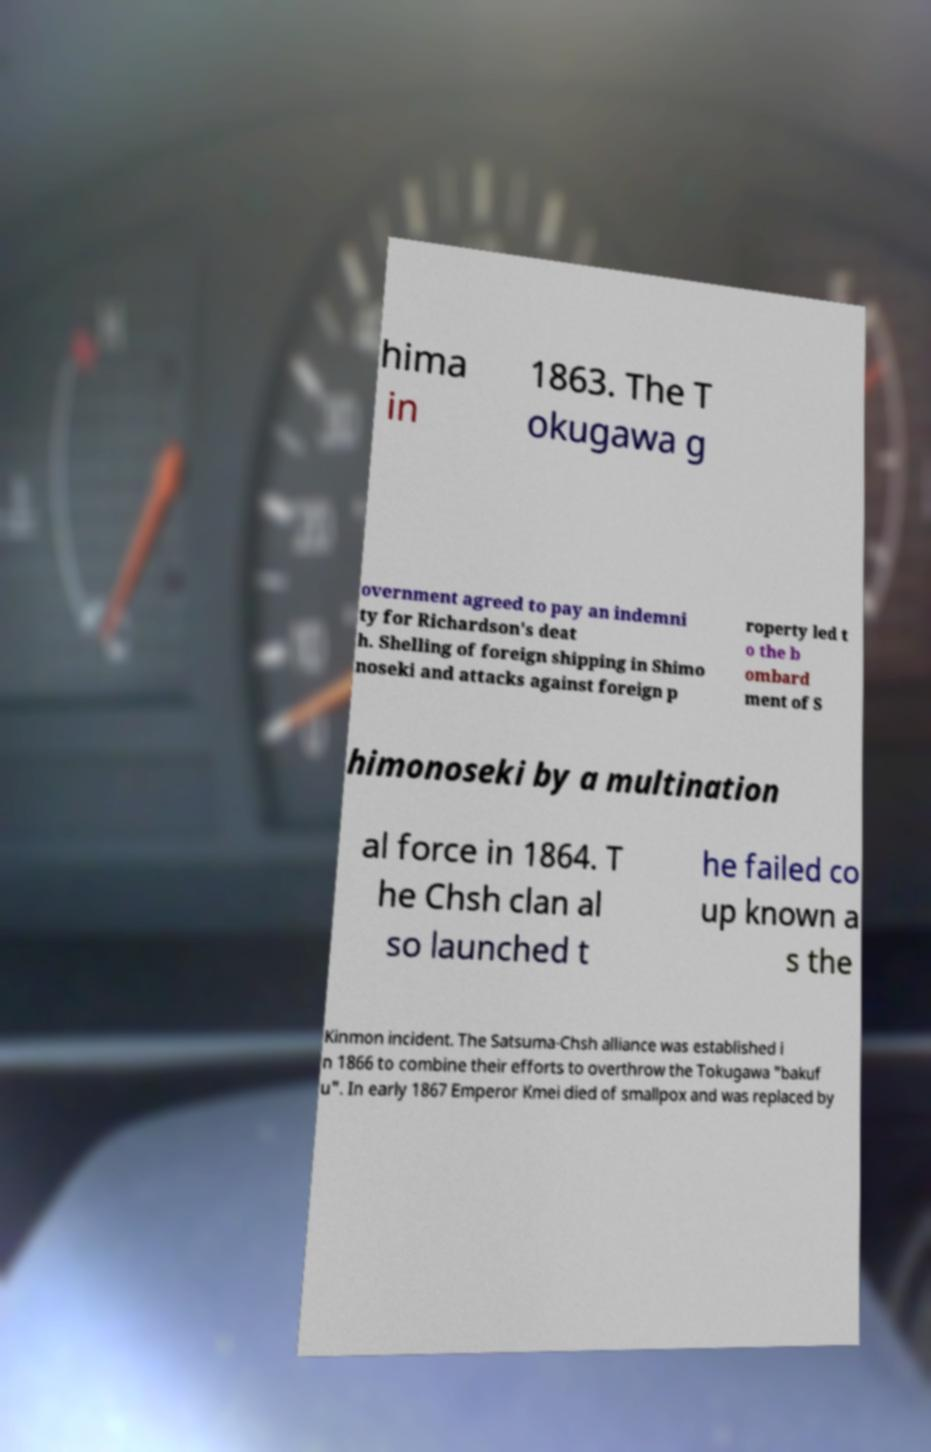I need the written content from this picture converted into text. Can you do that? hima in 1863. The T okugawa g overnment agreed to pay an indemni ty for Richardson's deat h. Shelling of foreign shipping in Shimo noseki and attacks against foreign p roperty led t o the b ombard ment of S himonoseki by a multination al force in 1864. T he Chsh clan al so launched t he failed co up known a s the Kinmon incident. The Satsuma-Chsh alliance was established i n 1866 to combine their efforts to overthrow the Tokugawa "bakuf u". In early 1867 Emperor Kmei died of smallpox and was replaced by 